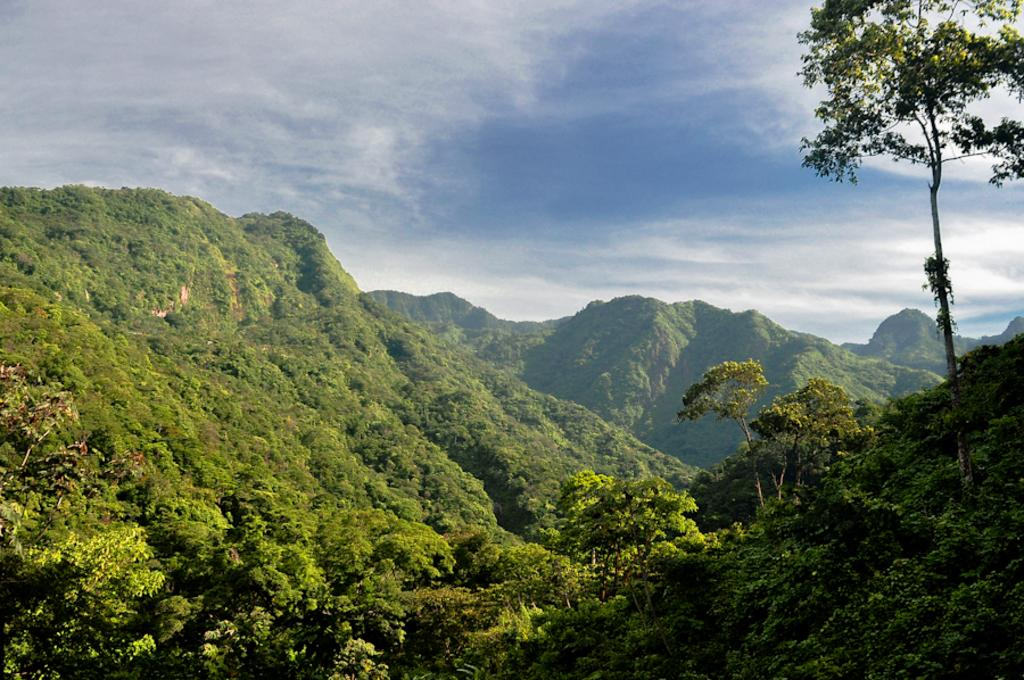What geographical feature is located in the center of the image? There are hills in the center of the image. What type of vegetation can be seen in the image? Trees are present in the image. What is visible in the sky at the top of the image? Clouds are visible in the sky at the top of the image. Can you see any ghosts interacting with the trees in the image? There are no ghosts present in the image; it only features hills, trees, and clouds. What type of interest rate is associated with the goldfish in the image? There are no goldfish present in the image, so it is not possible to determine any associated interest rates. 